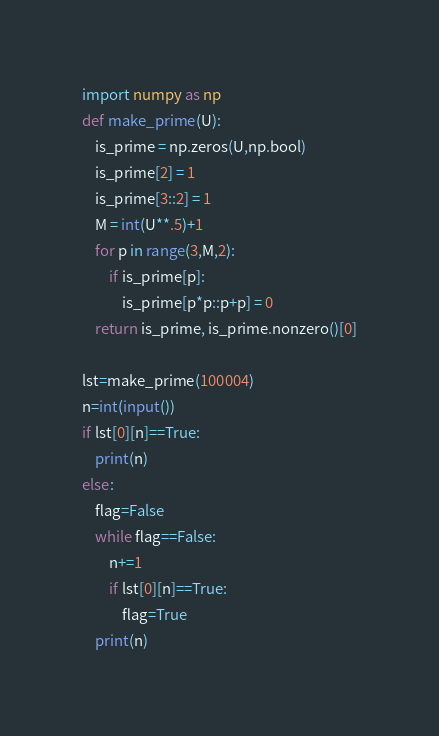Convert code to text. <code><loc_0><loc_0><loc_500><loc_500><_Python_>import numpy as np
def make_prime(U):
    is_prime = np.zeros(U,np.bool)
    is_prime[2] = 1
    is_prime[3::2] = 1
    M = int(U**.5)+1
    for p in range(3,M,2):
        if is_prime[p]:
            is_prime[p*p::p+p] = 0
    return is_prime, is_prime.nonzero()[0]

lst=make_prime(100004)
n=int(input())
if lst[0][n]==True:
    print(n)
else:
    flag=False
    while flag==False:
        n+=1
        if lst[0][n]==True:
            flag=True
    print(n)</code> 